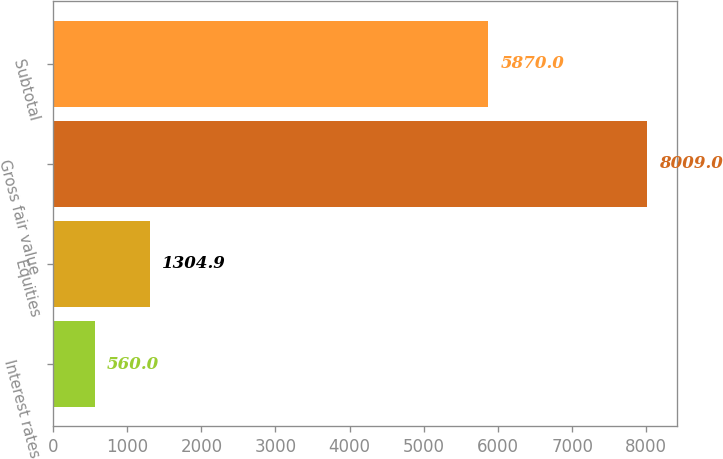Convert chart to OTSL. <chart><loc_0><loc_0><loc_500><loc_500><bar_chart><fcel>Interest rates<fcel>Equities<fcel>Gross fair value<fcel>Subtotal<nl><fcel>560<fcel>1304.9<fcel>8009<fcel>5870<nl></chart> 